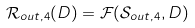<formula> <loc_0><loc_0><loc_500><loc_500>\mathcal { R } _ { o u t , 4 } ( D ) = \mathcal { F } ( \mathcal { S } _ { o u t , 4 } , D )</formula> 